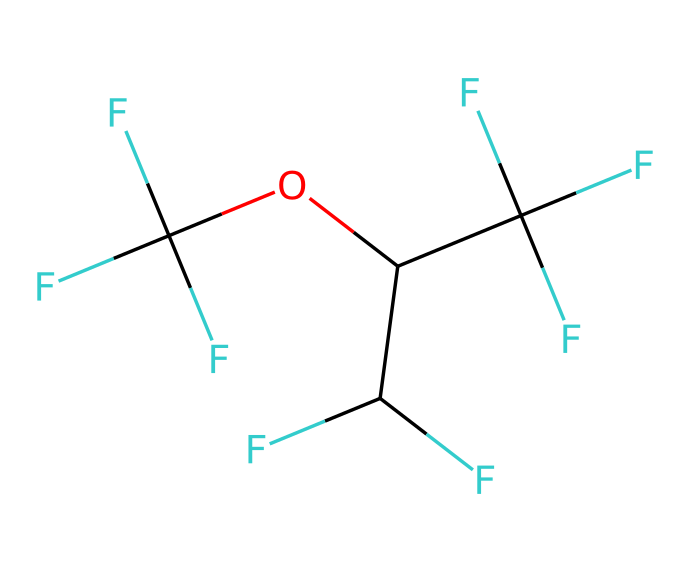What is the name of this chemical? The SMILES representation indicates a chemical structure with multiple fluorine atoms and an ether linkage, characteristic of anesthetics like sevoflurane.
Answer: sevoflurane How many carbon atoms are in sevoflurane? By analyzing the structure from the SMILES, there are three carbon atoms in the branching and one in the ether, totaling four carbon atoms.
Answer: four What is the total number of fluorine atoms in sevoflurane? The SMILES indicates there are five fluorine atoms attached to various carbon atoms, identified by the F symbols.
Answer: five What type of bond is predominant in sevoflurane? The structure contains carbon-fluorine and carbon-oxygen single bonds, which are the most prevalent types in this molecule.
Answer: single Why is sevoflurane classified as a gas at room temperature? The molecular structure shows a low molecular weight and non-polar character, leading to lower intermolecular forces that allow it to exist as a gas at room temperature.
Answer: low molecular weight Which functional group is present in sevoflurane? The chemical structure contains an ether functional group, identified by the carbon and oxygen connection within the molecule.
Answer: ether How many total bonds are present in the molecular structure of sevoflurane? Counting bonds from the SMILES representation shows several single bonds connecting carbon, fluorine, and oxygen atoms, totaling eight bonds.
Answer: eight 